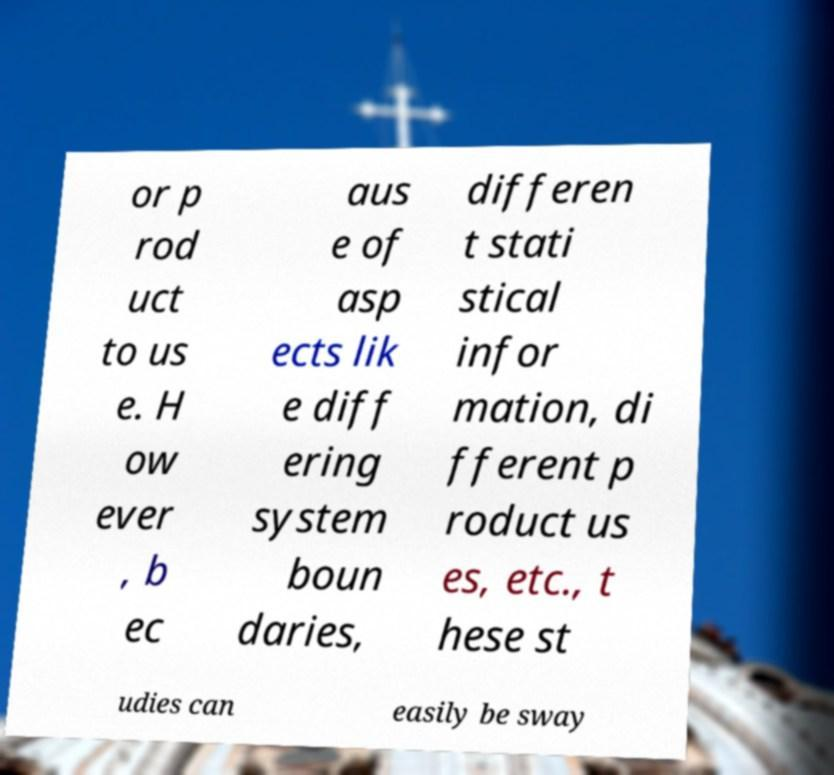I need the written content from this picture converted into text. Can you do that? or p rod uct to us e. H ow ever , b ec aus e of asp ects lik e diff ering system boun daries, differen t stati stical infor mation, di fferent p roduct us es, etc., t hese st udies can easily be sway 